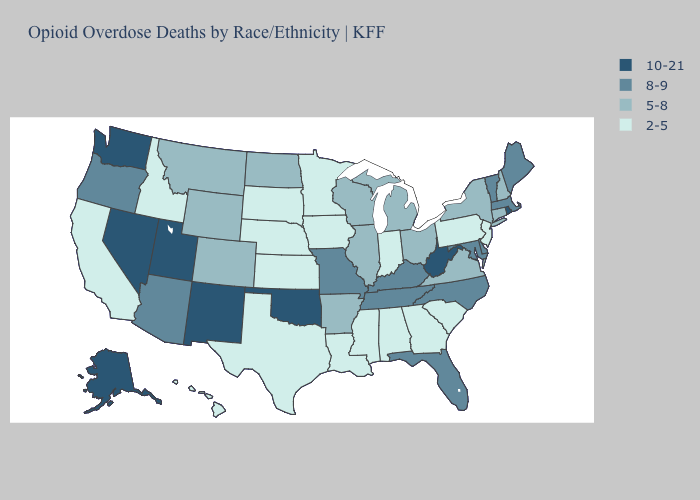Does Wisconsin have the highest value in the MidWest?
Answer briefly. No. Does Maine have a higher value than Texas?
Answer briefly. Yes. Does West Virginia have a higher value than Alaska?
Give a very brief answer. No. Name the states that have a value in the range 10-21?
Short answer required. Alaska, Nevada, New Mexico, Oklahoma, Rhode Island, Utah, Washington, West Virginia. Name the states that have a value in the range 5-8?
Give a very brief answer. Arkansas, Colorado, Connecticut, Illinois, Michigan, Montana, New Hampshire, New York, North Dakota, Ohio, Virginia, Wisconsin, Wyoming. Among the states that border Louisiana , does Arkansas have the highest value?
Give a very brief answer. Yes. Name the states that have a value in the range 8-9?
Quick response, please. Arizona, Delaware, Florida, Kentucky, Maine, Maryland, Massachusetts, Missouri, North Carolina, Oregon, Tennessee, Vermont. How many symbols are there in the legend?
Quick response, please. 4. What is the highest value in the USA?
Quick response, please. 10-21. Does the first symbol in the legend represent the smallest category?
Be succinct. No. Does Missouri have the highest value in the MidWest?
Quick response, please. Yes. What is the value of Montana?
Concise answer only. 5-8. Does Vermont have the lowest value in the Northeast?
Quick response, please. No. What is the value of Minnesota?
Write a very short answer. 2-5. Which states have the lowest value in the USA?
Give a very brief answer. Alabama, California, Georgia, Hawaii, Idaho, Indiana, Iowa, Kansas, Louisiana, Minnesota, Mississippi, Nebraska, New Jersey, Pennsylvania, South Carolina, South Dakota, Texas. 